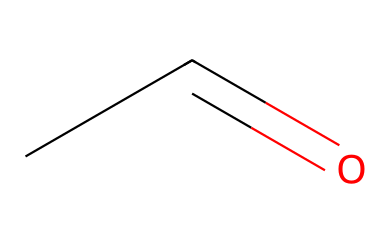What is the molecular formula of acetaldehyde? The SMILES representation CC=O corresponds to the molecule's structure, where C represents carbon atoms and O represents the oxygen atom. Counting the atoms gives us 2 carbon atoms, 4 hydrogen atoms, and 1 oxygen atom. Hence, the molecular formula is C2H4O.
Answer: C2H4O How many hydrogen atoms are present in acetaldehyde? By breaking down the SMILES CC=O, we can identify there are four hydrogen atoms attached to the two carbon atoms within the structure. The "=" denotes a double bond between the carbon and oxygen; thus, the total count of hydrogen is four.
Answer: 4 What type of functional group is present in acetaldehyde? The structure contains a carbonyl group (C=O) that is characteristic of aldehydes, where the carbon is bonded to at least one hydrogen atom. Since the structure has this carbonyl group and at least one hydrogen directly attached to the carbon double-bonded to oxygen, it confirms the presence of an aldehyde functional group.
Answer: aldehyde Does acetaldehyde have any double bonds? Reviewing the SMILES representation, the notation “C=O” indicates a double bond between a carbon atom and an oxygen atom. As aldehydes are defined by the presence of this carbonyl group, it confirms that acetaldehyde does indeed feature a double bond in its structure.
Answer: yes What is the characteristic smell of acetaldehyde? Acetaldehyde, being an aldehyde, is known for its pungent, fruity odor. This characteristic is derived from the aldehyde functional group and is often associated with the scent of ripe fruits, which can be off-putting or strong when concentrated.
Answer: fruity 